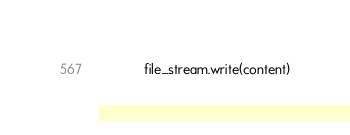<code> <loc_0><loc_0><loc_500><loc_500><_Python_>            file_stream.write(content)
</code> 